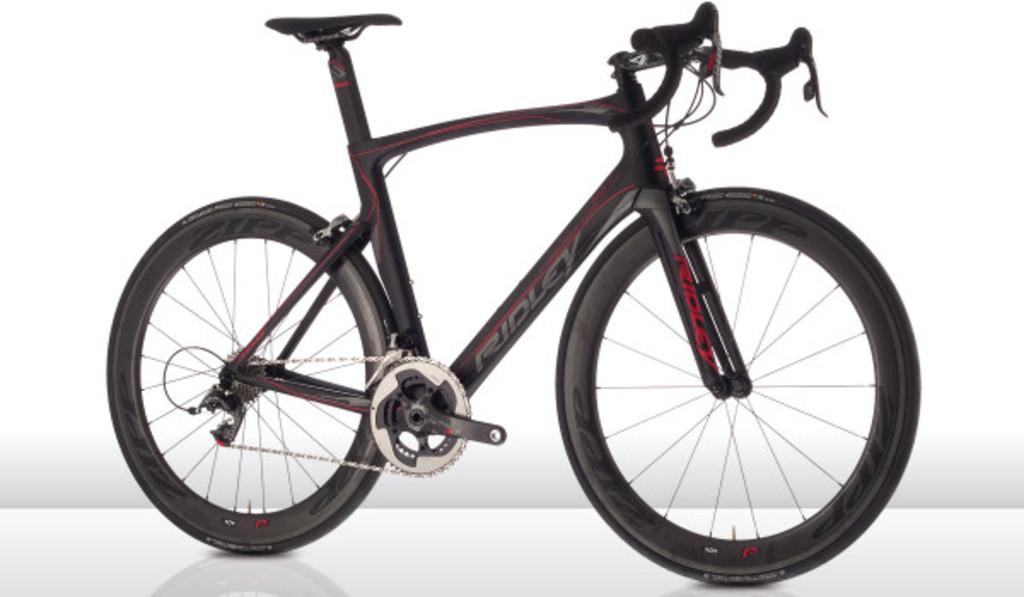Describe this image in one or two sentences. In this picture I can see a bicycle, and there is white background. 